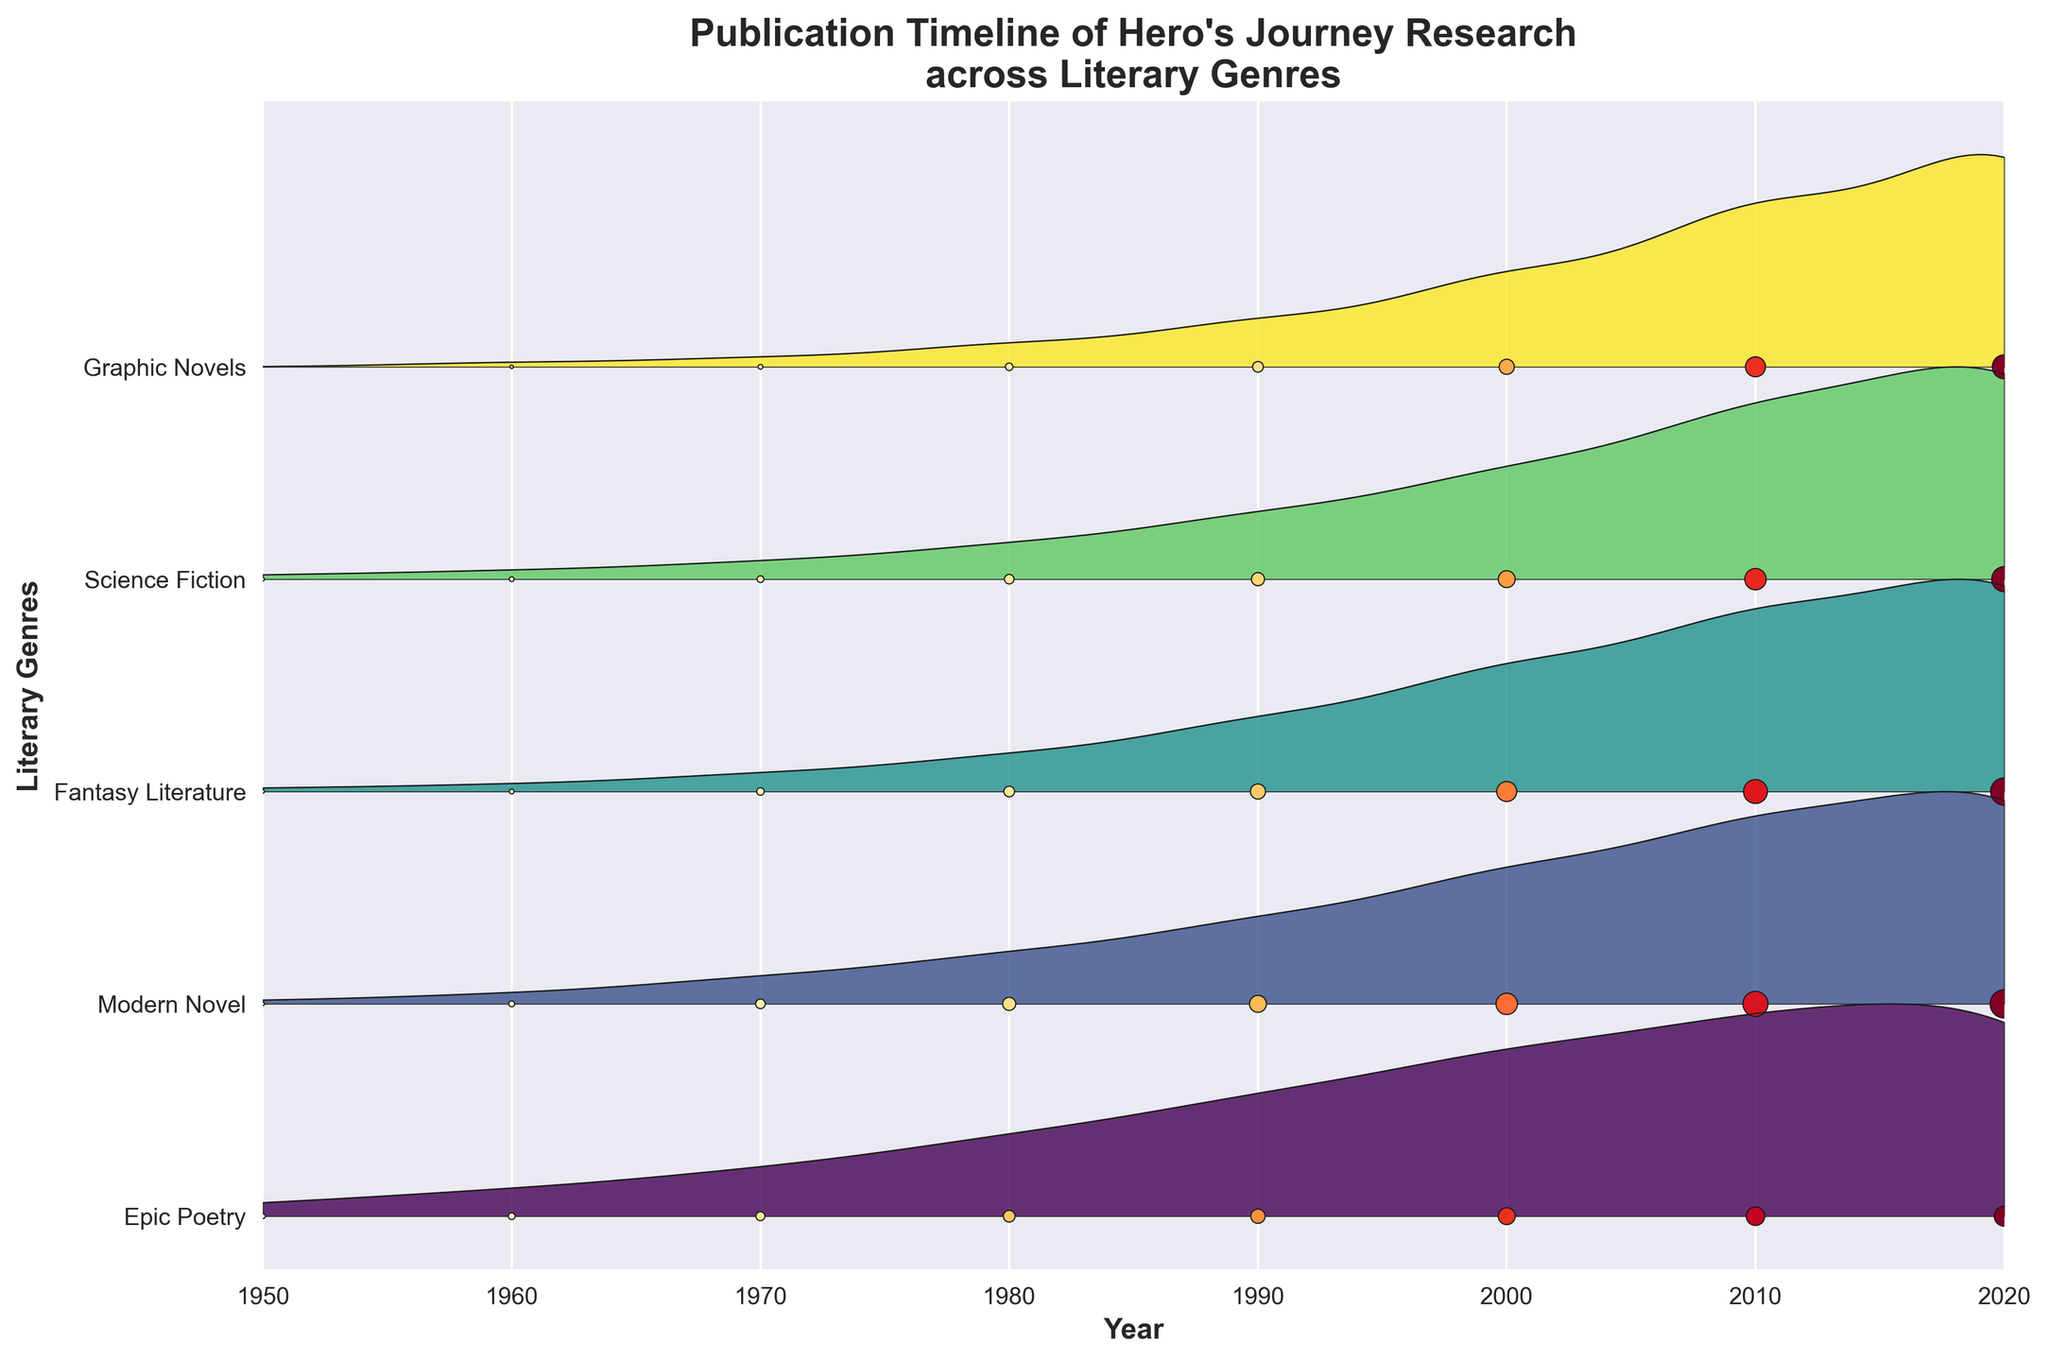What's the title of the figure? The title of the figure is usually located at the top and describes the overall subject of the graph. In this case, the figure's title is "Publication Timeline of Hero's Journey Research across Literary Genres".
Answer: Publication Timeline of Hero's Journey Research across Literary Genres How many literary genres are analyzed in the figure? The y-axis of the figure lists each literary genre analyzed. Count the number of unique categories listed to find the total number. There are five genres analyzed.
Answer: Five Which literary genre showed the highest number of publications in 2020? The x-axis represents years, while the vertical extent for each genre indicates the number of publications. The genre with the highest vertical extent at 2020 is "Modern Novel".
Answer: Modern Novel What overall trend can be observed in the publication counts across all genres from 1950 to 2020? Observing the figure, the vertical extent and the number of data points increase from left to right (1950 to 2020) for all genres. This indicates an upward trend in publication counts over time.
Answer: Increasing trend Between which years did Fantasy Literature see the most rapid increase in publications? Analyzing the y-scales for "Fantasy Literature", the publications grew significantly between 1990 and 2000 (a steep incline is visible).
Answer: 1990-2000 Which two genres had a similar number of publications around 1980? Around the 1980 mark on the figure, both "Modern Novel" and "Fantasy Literature" have similar visual heights, indicating approximately similar publication numbers.
Answer: Modern Novel and Fantasy Literature Compared to Graphic Novels, did Science Fiction publications grow faster between 2000 and 2020? By comparing the figure's visual heights for these two genres between 2000 and 2020, we can see that both genres grow, but Science Fiction has slightly less increase, as indicated by the vertical height.
Answer: No Which genre started with the least publications in 1950? The data points at 1950 show a minimal or zero count. Observing the figure, "Graphic Novels" begins with zero publications.
Answer: Graphic Novels How does the publication activity in Epic Poetry from 1950 to 2020 compare with that in Modern Novel over the same period? By visually comparing the ridges for both genres, we see that "Epic Poetry" remains lower overall compared to the much higher and increasing trend in "Modern Novel".
Answer: Modern Novel is much higher than Epic Poetry What pattern can be observed in the publication counts for Science Fiction as compared to Fantasy Literature between 1980 and 2000? By closely examining the visual heights for those years in both genres, we observe that "Fantasy Literature" experiences a much steeper incline, indicating more rapid publication growth compared to "Science Fiction".
Answer: Fantasy Literature grows faster 